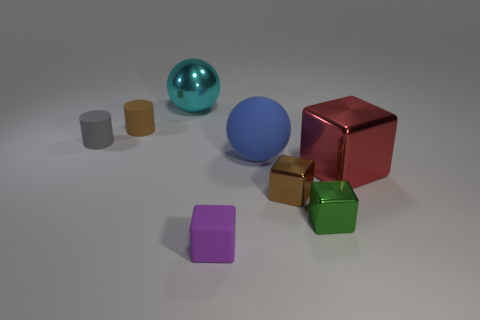Add 1 cylinders. How many objects exist? 9 Subtract all balls. How many objects are left? 6 Add 7 purple rubber objects. How many purple rubber objects exist? 8 Subtract 0 cyan blocks. How many objects are left? 8 Subtract all small red cubes. Subtract all blue matte balls. How many objects are left? 7 Add 7 tiny green cubes. How many tiny green cubes are left? 8 